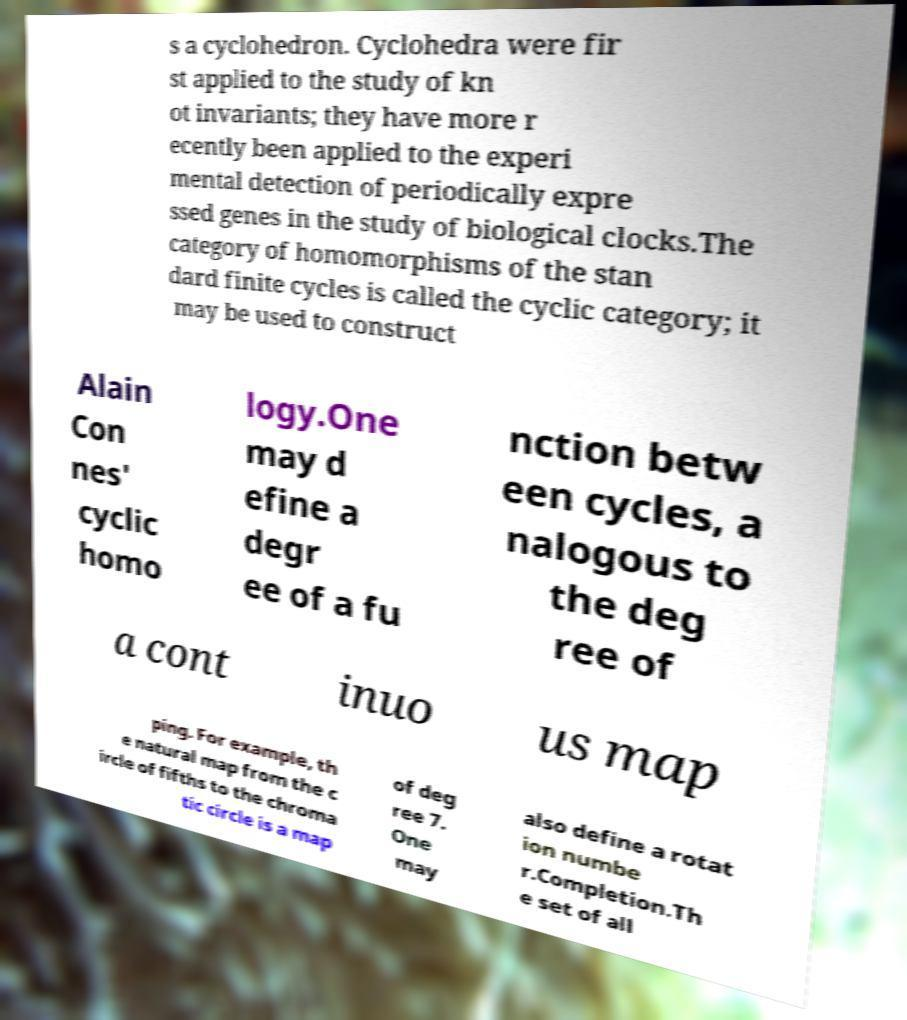Can you accurately transcribe the text from the provided image for me? s a cyclohedron. Cyclohedra were fir st applied to the study of kn ot invariants; they have more r ecently been applied to the experi mental detection of periodically expre ssed genes in the study of biological clocks.The category of homomorphisms of the stan dard finite cycles is called the cyclic category; it may be used to construct Alain Con nes' cyclic homo logy.One may d efine a degr ee of a fu nction betw een cycles, a nalogous to the deg ree of a cont inuo us map ping. For example, th e natural map from the c ircle of fifths to the chroma tic circle is a map of deg ree 7. One may also define a rotat ion numbe r.Completion.Th e set of all 